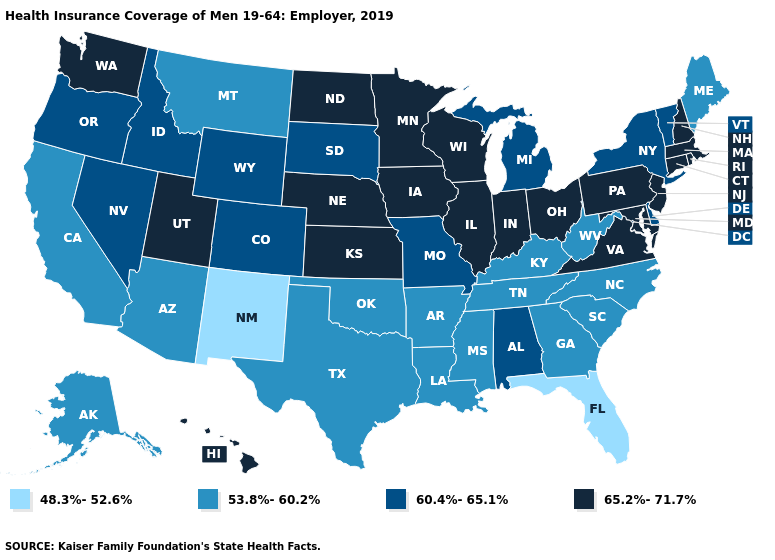Does South Dakota have a higher value than Montana?
Short answer required. Yes. Is the legend a continuous bar?
Give a very brief answer. No. What is the value of Tennessee?
Answer briefly. 53.8%-60.2%. Name the states that have a value in the range 60.4%-65.1%?
Answer briefly. Alabama, Colorado, Delaware, Idaho, Michigan, Missouri, Nevada, New York, Oregon, South Dakota, Vermont, Wyoming. Name the states that have a value in the range 48.3%-52.6%?
Concise answer only. Florida, New Mexico. Which states have the lowest value in the USA?
Concise answer only. Florida, New Mexico. What is the value of Wyoming?
Give a very brief answer. 60.4%-65.1%. Does Illinois have a higher value than Arkansas?
Concise answer only. Yes. Does the map have missing data?
Give a very brief answer. No. Does the first symbol in the legend represent the smallest category?
Answer briefly. Yes. What is the highest value in the USA?
Answer briefly. 65.2%-71.7%. Does Alabama have the highest value in the South?
Answer briefly. No. What is the value of Maine?
Concise answer only. 53.8%-60.2%. Is the legend a continuous bar?
Answer briefly. No. Does Rhode Island have the same value as Utah?
Keep it brief. Yes. 